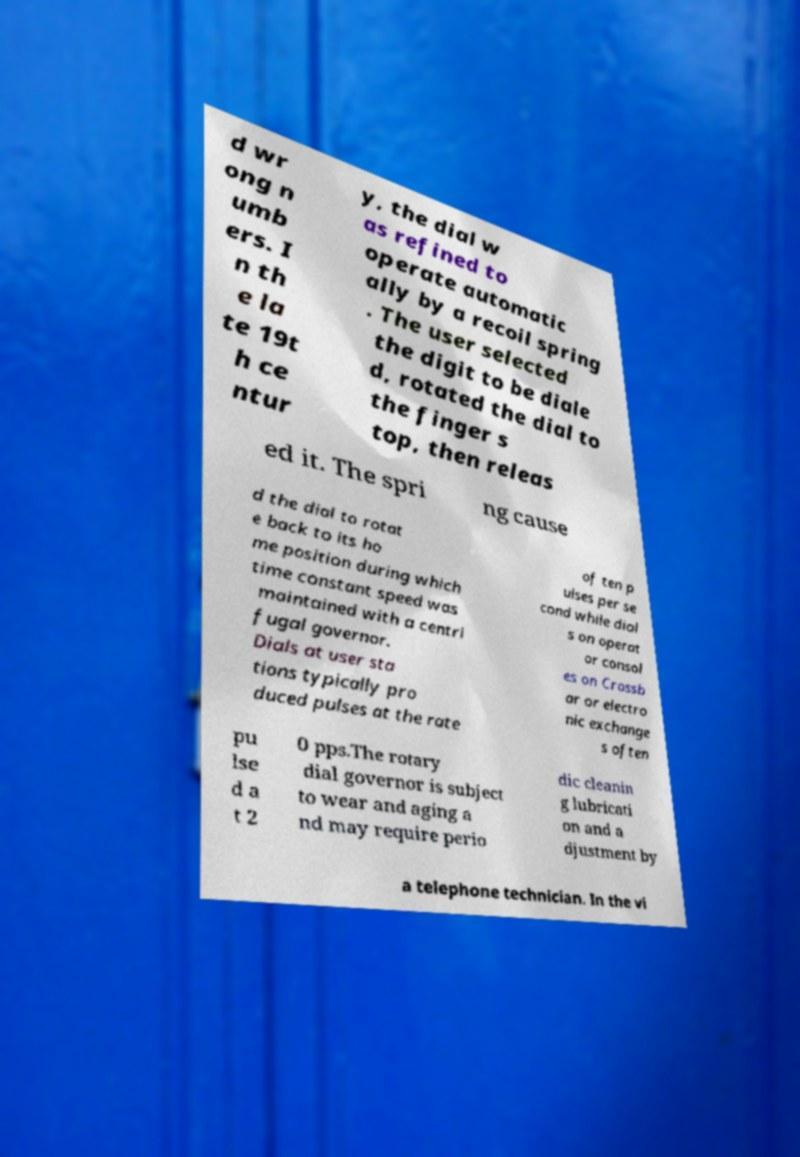Please identify and transcribe the text found in this image. d wr ong n umb ers. I n th e la te 19t h ce ntur y, the dial w as refined to operate automatic ally by a recoil spring . The user selected the digit to be diale d, rotated the dial to the finger s top, then releas ed it. The spri ng cause d the dial to rotat e back to its ho me position during which time constant speed was maintained with a centri fugal governor. Dials at user sta tions typically pro duced pulses at the rate of ten p ulses per se cond while dial s on operat or consol es on Crossb ar or electro nic exchange s often pu lse d a t 2 0 pps.The rotary dial governor is subject to wear and aging a nd may require perio dic cleanin g lubricati on and a djustment by a telephone technician. In the vi 